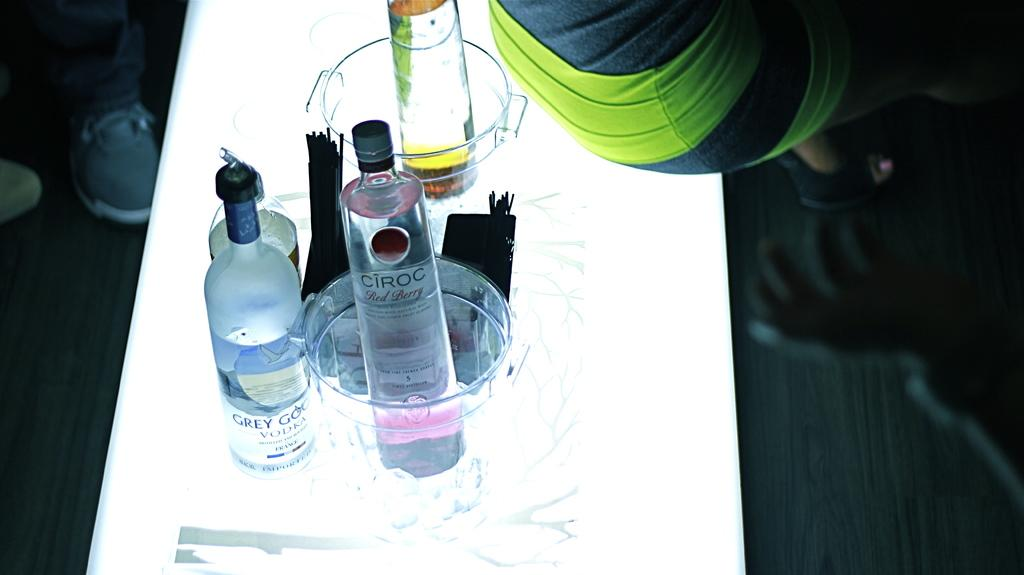Who is present in the image? There is a person in the image. What is the person wearing? The person is wearing a black and green dress. What is the person doing in the image? The person is sitting on a table. What other objects are on the table? There are glasses and bottles on the table. What type of sugar is the person thinking about in the image? There is no indication in the image that the person is thinking about sugar, so it cannot be determined from the picture. 